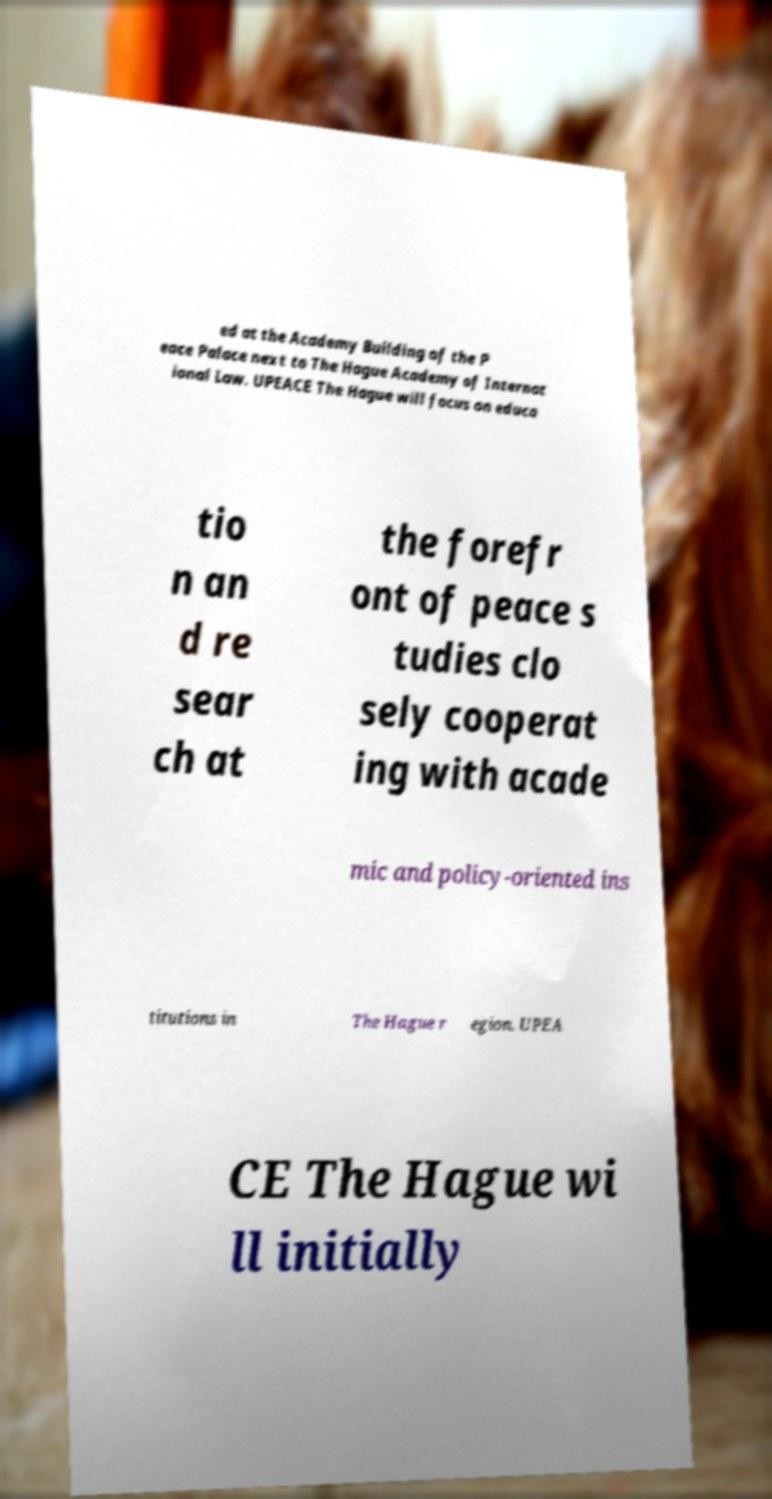What messages or text are displayed in this image? I need them in a readable, typed format. ed at the Academy Building of the P eace Palace next to The Hague Academy of Internat ional Law. UPEACE The Hague will focus on educa tio n an d re sear ch at the forefr ont of peace s tudies clo sely cooperat ing with acade mic and policy-oriented ins titutions in The Hague r egion. UPEA CE The Hague wi ll initially 